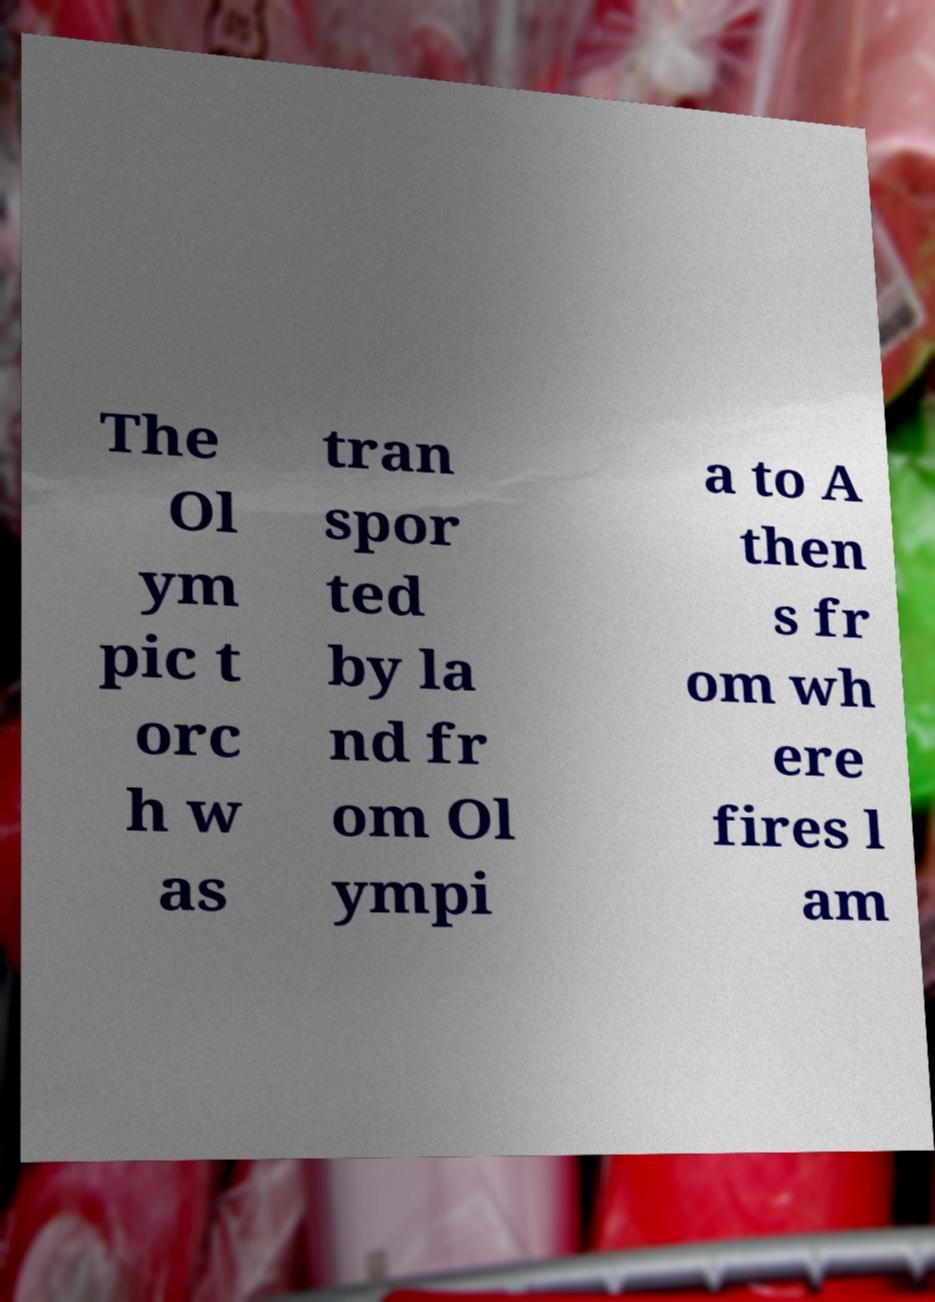What messages or text are displayed in this image? I need them in a readable, typed format. The Ol ym pic t orc h w as tran spor ted by la nd fr om Ol ympi a to A then s fr om wh ere fires l am 